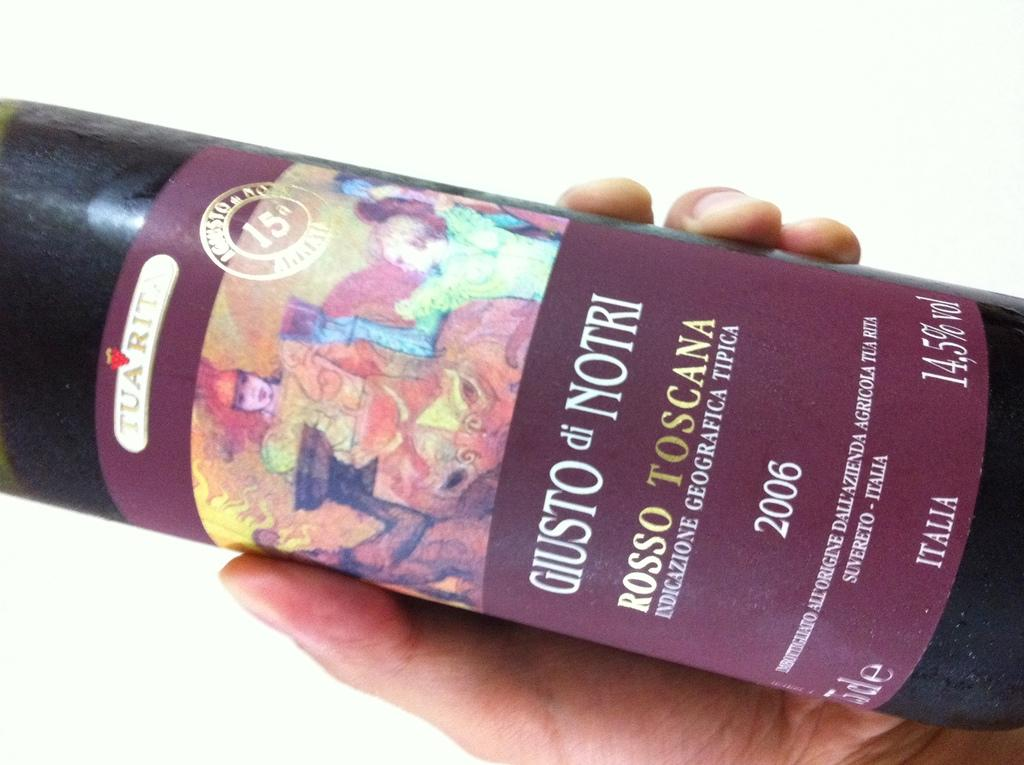<image>
Share a concise interpretation of the image provided. A bottle of Gusto di Notri 2006 wine with a colorful label. 